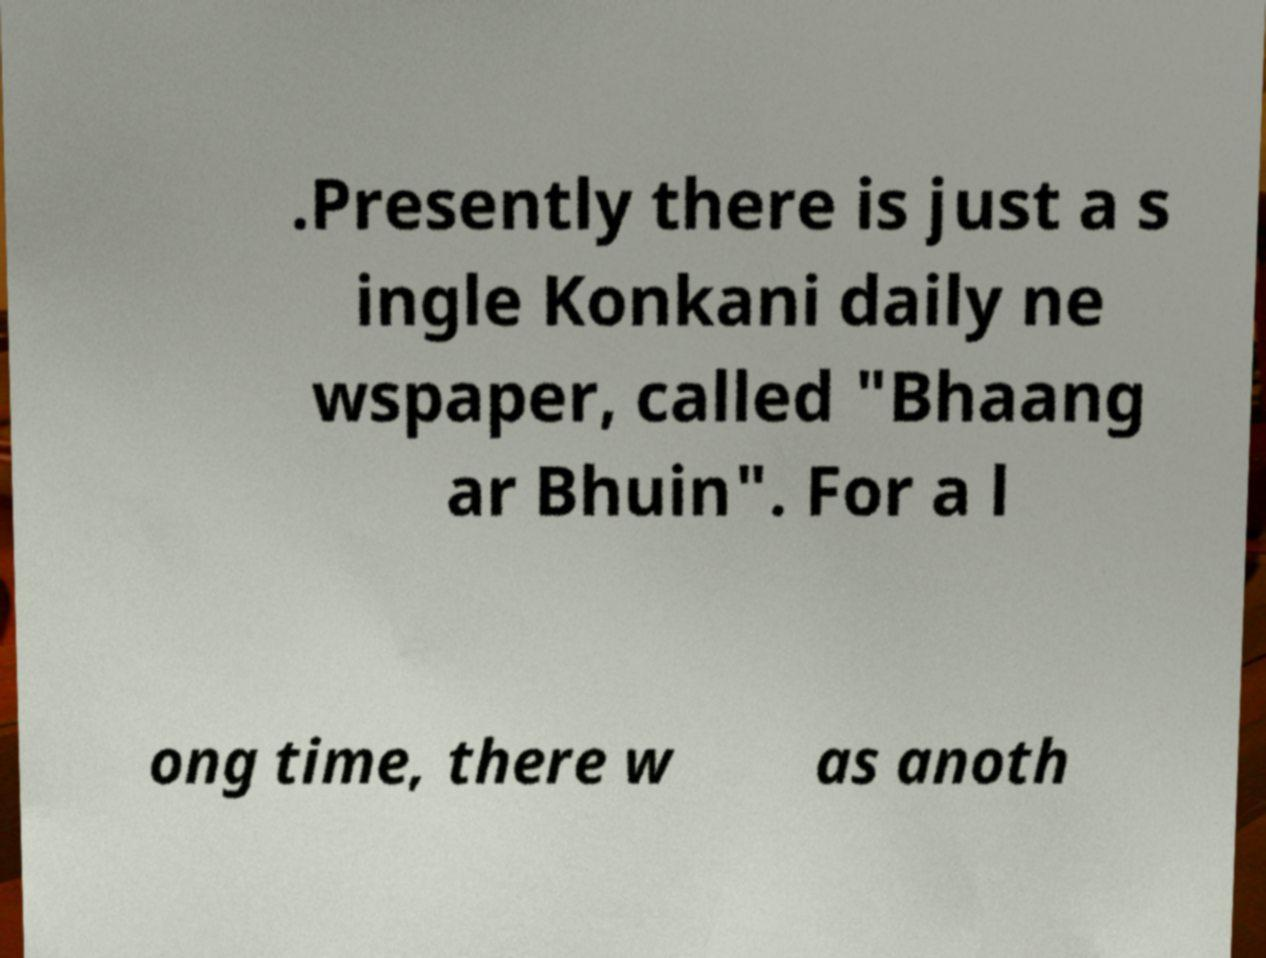I need the written content from this picture converted into text. Can you do that? .Presently there is just a s ingle Konkani daily ne wspaper, called "Bhaang ar Bhuin". For a l ong time, there w as anoth 